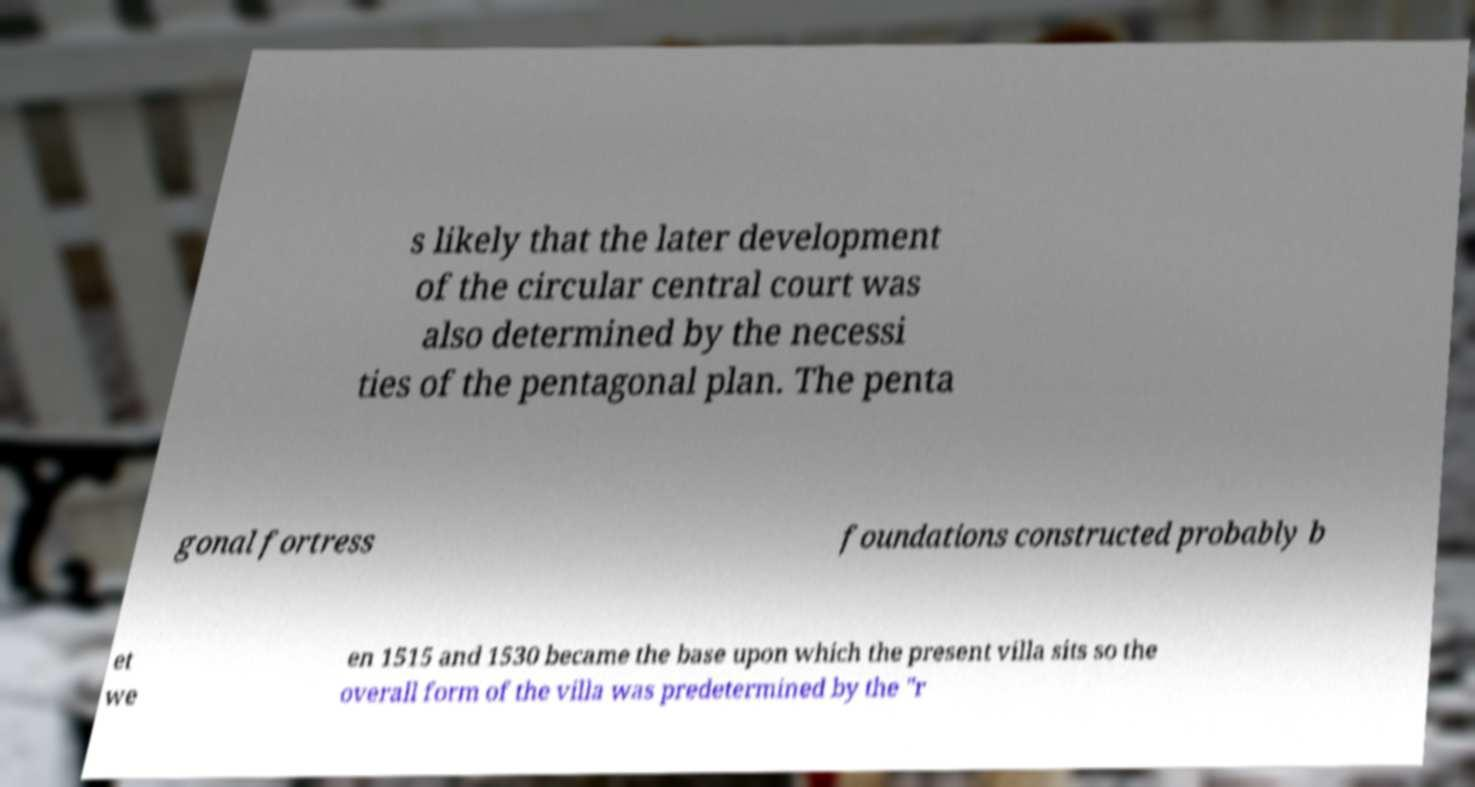Can you read and provide the text displayed in the image?This photo seems to have some interesting text. Can you extract and type it out for me? s likely that the later development of the circular central court was also determined by the necessi ties of the pentagonal plan. The penta gonal fortress foundations constructed probably b et we en 1515 and 1530 became the base upon which the present villa sits so the overall form of the villa was predetermined by the "r 